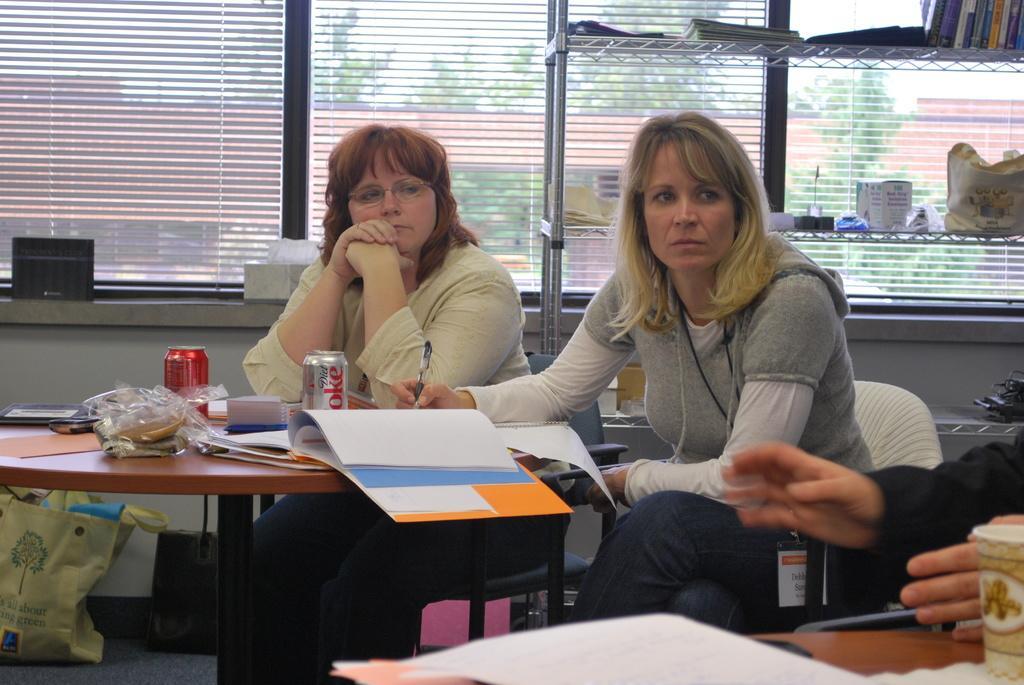Can you describe this image briefly? There are two women sitting on the chair. This is a table. These are the two coke tins,file,papers and few other things on it. I can see books,bag and few other object placed on the rack. I can see two bags placed on the floor. This is the window covered with sheet. At the right corner of the image I can see person hand. This is the another table with paper,glass placed on it. 